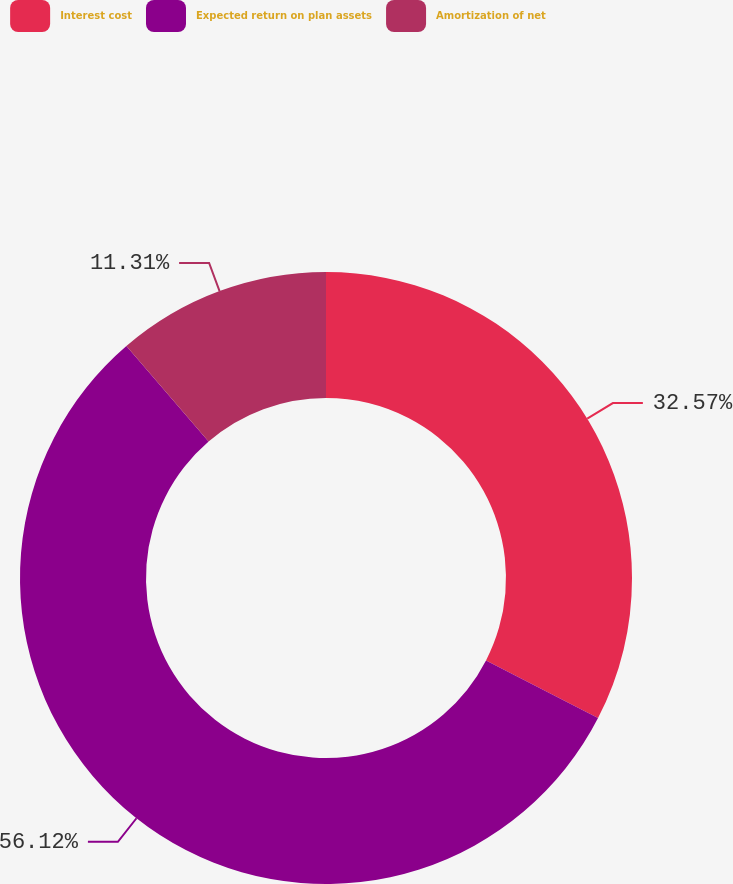Convert chart. <chart><loc_0><loc_0><loc_500><loc_500><pie_chart><fcel>Interest cost<fcel>Expected return on plan assets<fcel>Amortization of net<nl><fcel>32.57%<fcel>56.12%<fcel>11.31%<nl></chart> 